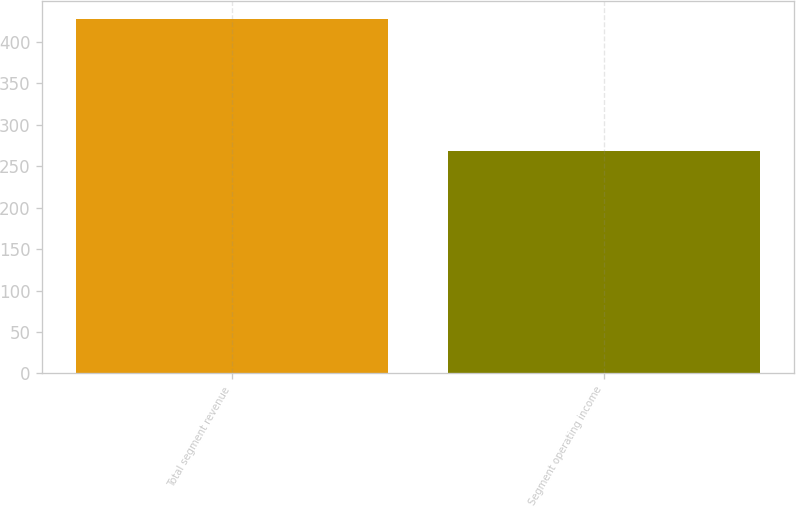Convert chart to OTSL. <chart><loc_0><loc_0><loc_500><loc_500><bar_chart><fcel>Total segment revenue<fcel>Segment operating income<nl><fcel>428<fcel>268<nl></chart> 